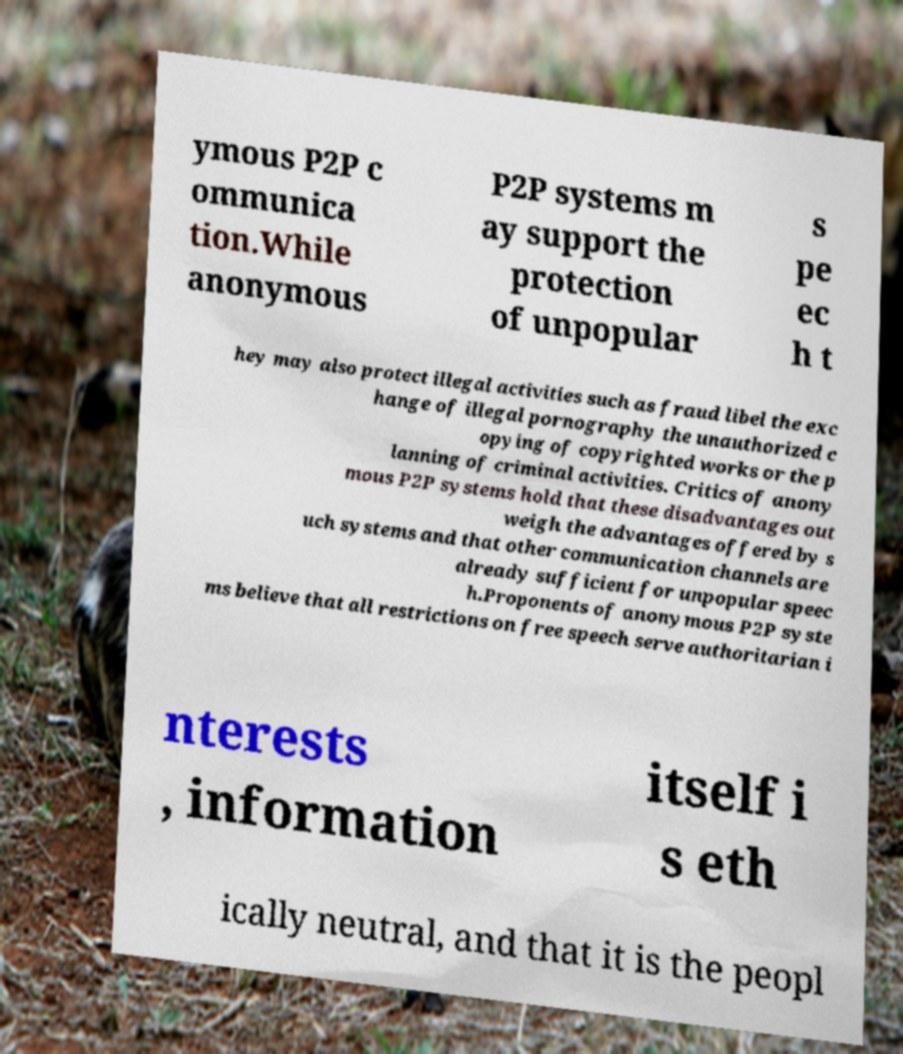Can you accurately transcribe the text from the provided image for me? ymous P2P c ommunica tion.While anonymous P2P systems m ay support the protection of unpopular s pe ec h t hey may also protect illegal activities such as fraud libel the exc hange of illegal pornography the unauthorized c opying of copyrighted works or the p lanning of criminal activities. Critics of anony mous P2P systems hold that these disadvantages out weigh the advantages offered by s uch systems and that other communication channels are already sufficient for unpopular speec h.Proponents of anonymous P2P syste ms believe that all restrictions on free speech serve authoritarian i nterests , information itself i s eth ically neutral, and that it is the peopl 